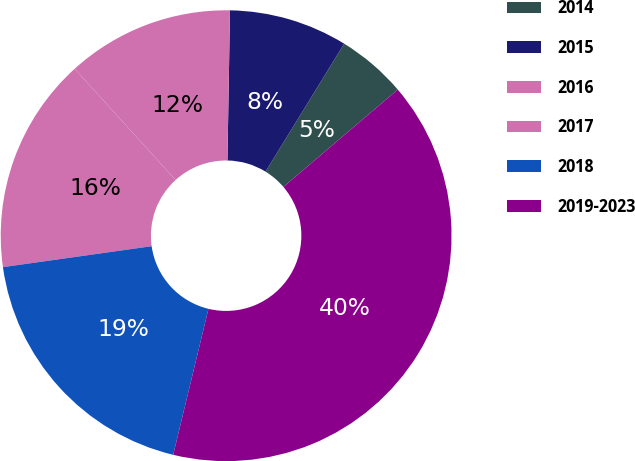<chart> <loc_0><loc_0><loc_500><loc_500><pie_chart><fcel>2014<fcel>2015<fcel>2016<fcel>2017<fcel>2018<fcel>2019-2023<nl><fcel>5.0%<fcel>8.5%<fcel>12.0%<fcel>15.5%<fcel>19.0%<fcel>40.0%<nl></chart> 